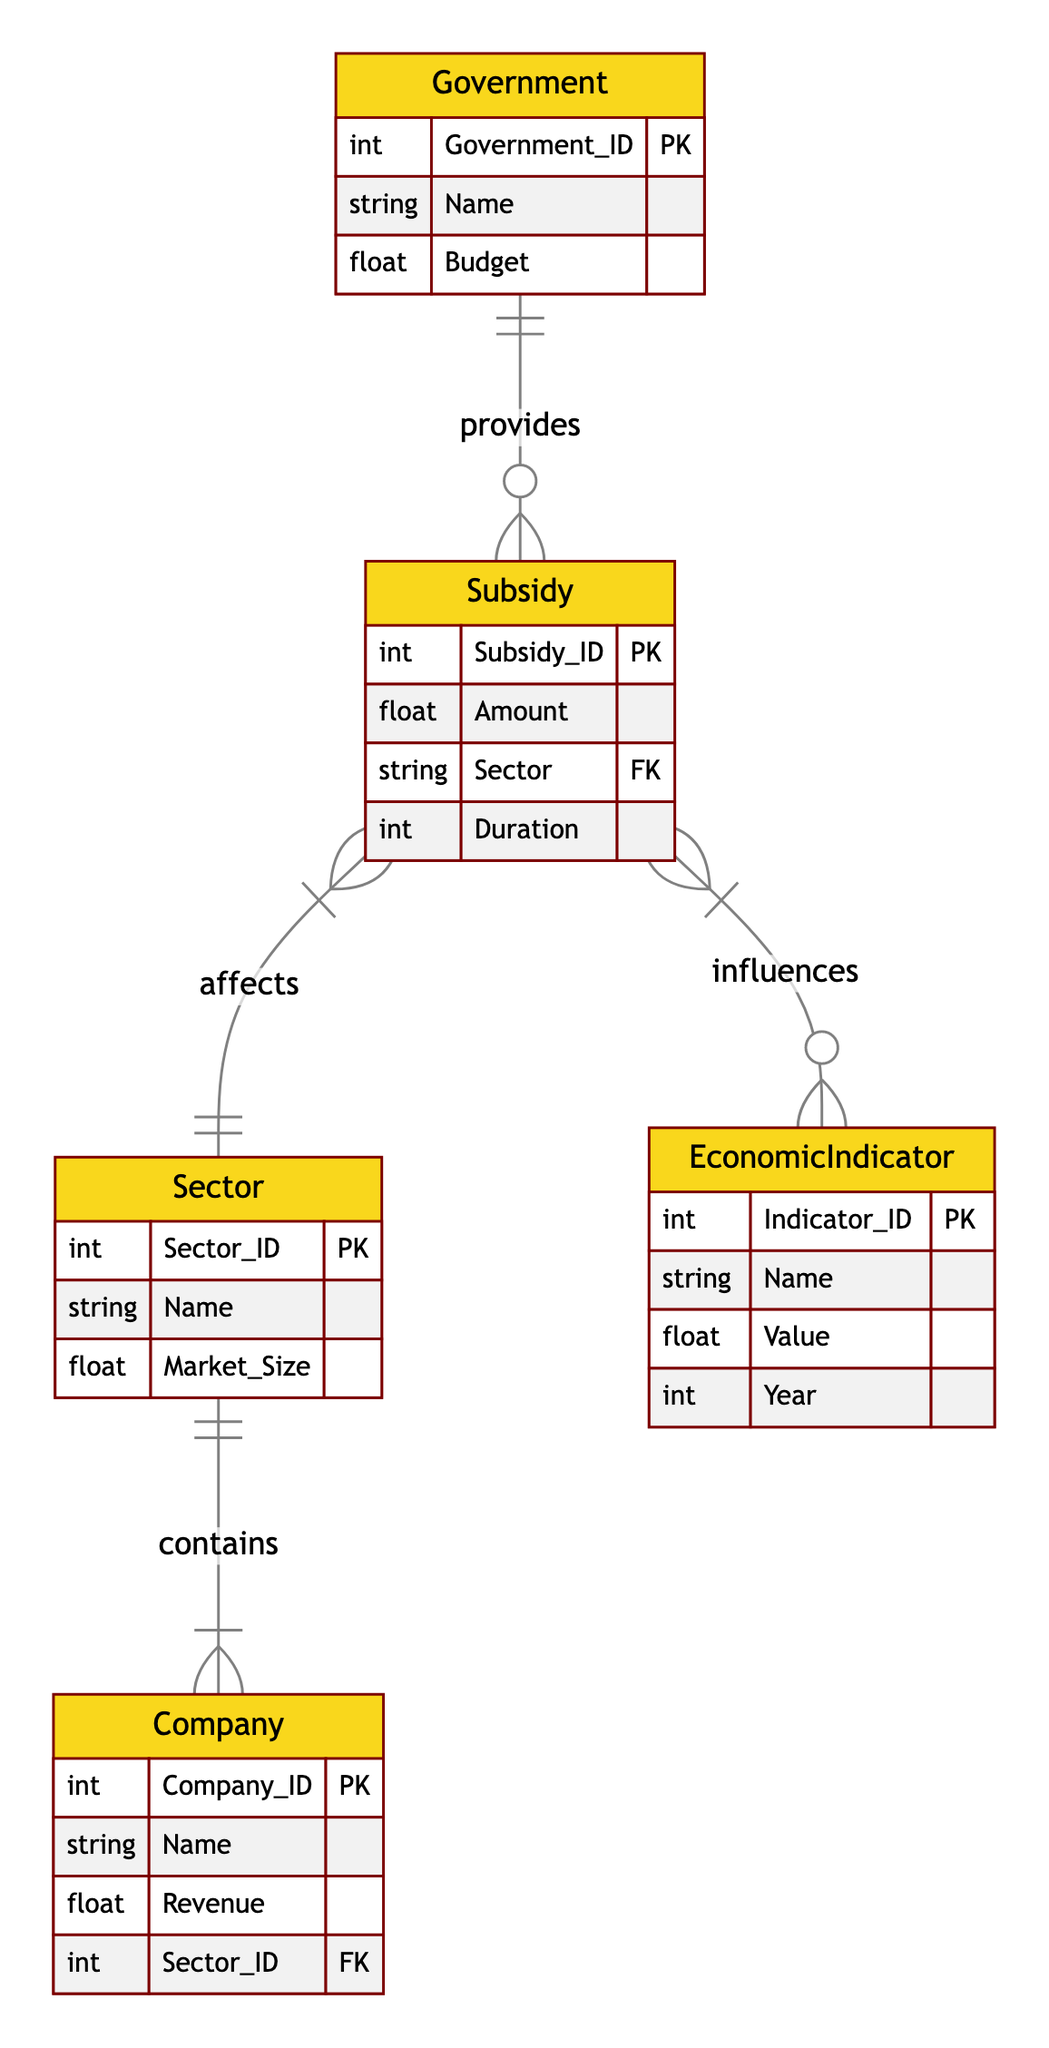What entities are involved in government subsidies? The diagram lists three entities that interact with government subsidies: Government, Subsidy, and Sector. The relationships indicate that the Government provides Subsidies, which affect Sectors.
Answer: Government, Subsidy, Sector How many attributes does the Company entity have? The Company entity has four attributes: Company_ID, Name, Revenue, and Sector_ID. This is observed directly from the definition of the Company entity in the diagram.
Answer: Four What relationship exists between Subsidy and EconomicIndicator? The relationship between Subsidy and EconomicIndicator is described as "influences," meaning that Subsidies have an effect on Economic Indicators according to the diagram's relationships.
Answer: Influences Which entity contains the Sector? The Sector entity is contained in the Company entity as indicated by the relationship "contains," meaning that Companies are categorized under specific Sectors.
Answer: Company What is the primary key of the Subsidy entity? The primary key for the Subsidy entity is Subsidy_ID, which uniquely identifies each record of the Subsidy entity according to standard entity-relationship design.
Answer: Subsidy_ID How does the Government affect the market through Subsidies? The Government affects the market by providing Subsidies, and each Subsidy is specified for a different Sector, thereby guiding investment and economic activity in those areas. This is derived from the relationships of the Government entity with the Subsidy entity.
Answer: Provides What is the minimum number of Sectors involved in the diagram? Each Subsidy must correspond to at least one Sector according to the diagram structure, meaning that there is at least one Sector involved; hence, the minimum is one. This response combines the understanding of relationships from the Subsidy entity.
Answer: One How many entities have a direct influence from the Subsidy? The Subsidy entity has direct influences on two entities: Sector and EconomicIndicator. This is derived from the direct relationships shown in the diagram.
Answer: Two 